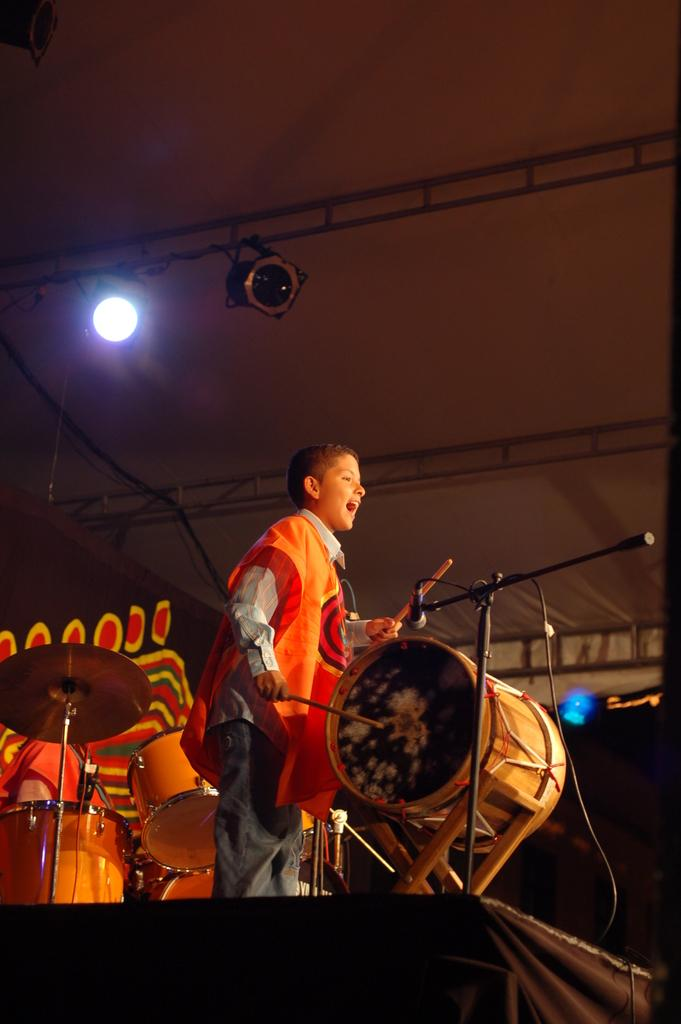Who is the main subject in the image? There is a boy in the image. What is the boy doing in the image? The boy is playing drums. What is in front of the boy? There is a microphone in front of the boy. What is behind the boy? There is a drum set behind the boy. What can be seen illuminating the scene from above? A light is focused from the top in the image. What type of furniture is being used to cover the grapes in the image? There are no grapes or furniture present in the image. 